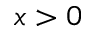<formula> <loc_0><loc_0><loc_500><loc_500>x > 0</formula> 